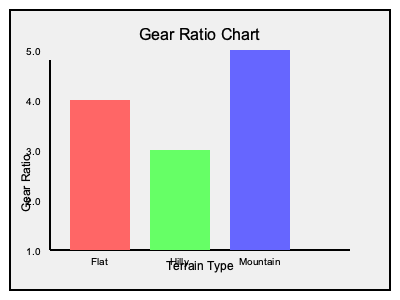Based on the gear ratio chart provided, which terrain type requires the widest range of gear ratios, and what is the approximate difference between its highest and lowest gear ratios? To answer this question, we need to analyze the gear ratio chart for each terrain type:

1. Flat terrain (red bar):
   - Ranges from approximately 2.5 to 4.0
   - Range: 4.0 - 2.5 = 1.5

2. Hilly terrain (green bar):
   - Ranges from approximately 2.0 to 3.0
   - Range: 3.0 - 2.0 = 1.0

3. Mountain terrain (blue bar):
   - Ranges from approximately 1.5 to 4.5
   - Range: 4.5 - 1.5 = 3.0

The terrain type with the widest range of gear ratios is the mountain terrain, represented by the blue bar. It has the largest vertical span on the chart.

To calculate the approximate difference between the highest and lowest gear ratios for mountain terrain:

$$ \text{Difference} = \text{Highest ratio} - \text{Lowest ratio} $$
$$ \text{Difference} \approx 4.5 - 1.5 = 3.0 $$

Therefore, the mountain terrain requires the widest range of gear ratios, with an approximate difference of 3.0 between its highest and lowest gear ratios.
Answer: Mountain terrain; 3.0 